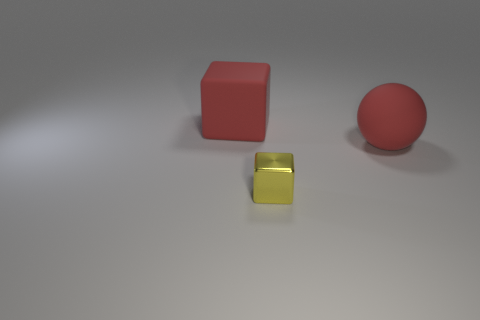Subtract all red cubes. Subtract all blue balls. How many cubes are left? 1 Add 1 red rubber balls. How many objects exist? 4 Subtract all cubes. How many objects are left? 1 Add 3 large green rubber spheres. How many large green rubber spheres exist? 3 Subtract 0 purple blocks. How many objects are left? 3 Subtract all small yellow things. Subtract all large yellow spheres. How many objects are left? 2 Add 1 yellow shiny blocks. How many yellow shiny blocks are left? 2 